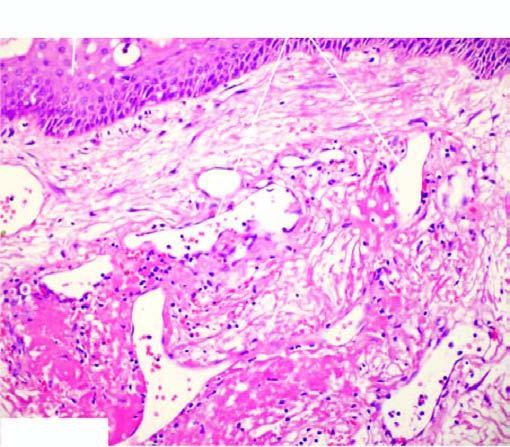what has intact surface epithelium?
Answer the question using a single word or phrase. Lesion 